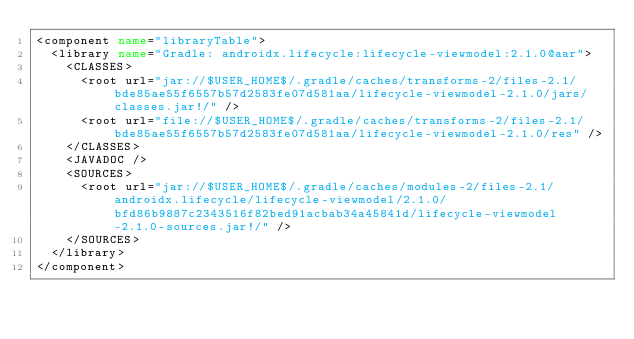<code> <loc_0><loc_0><loc_500><loc_500><_XML_><component name="libraryTable">
  <library name="Gradle: androidx.lifecycle:lifecycle-viewmodel:2.1.0@aar">
    <CLASSES>
      <root url="jar://$USER_HOME$/.gradle/caches/transforms-2/files-2.1/bde85ae55f6557b57d2583fe07d581aa/lifecycle-viewmodel-2.1.0/jars/classes.jar!/" />
      <root url="file://$USER_HOME$/.gradle/caches/transforms-2/files-2.1/bde85ae55f6557b57d2583fe07d581aa/lifecycle-viewmodel-2.1.0/res" />
    </CLASSES>
    <JAVADOC />
    <SOURCES>
      <root url="jar://$USER_HOME$/.gradle/caches/modules-2/files-2.1/androidx.lifecycle/lifecycle-viewmodel/2.1.0/bfd86b9887c2343516f82bed91acbab34a45841d/lifecycle-viewmodel-2.1.0-sources.jar!/" />
    </SOURCES>
  </library>
</component></code> 